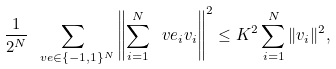Convert formula to latex. <formula><loc_0><loc_0><loc_500><loc_500>\frac { 1 } { 2 ^ { N } } \sum _ { \ v e \in \{ - 1 , 1 \} ^ { N } } \left \| \sum _ { i = 1 } ^ { N } \ v e _ { i } v _ { i } \right \| ^ { 2 } \leq K ^ { 2 } \sum _ { i = 1 } ^ { N } \| v _ { i } \| ^ { 2 } ,</formula> 